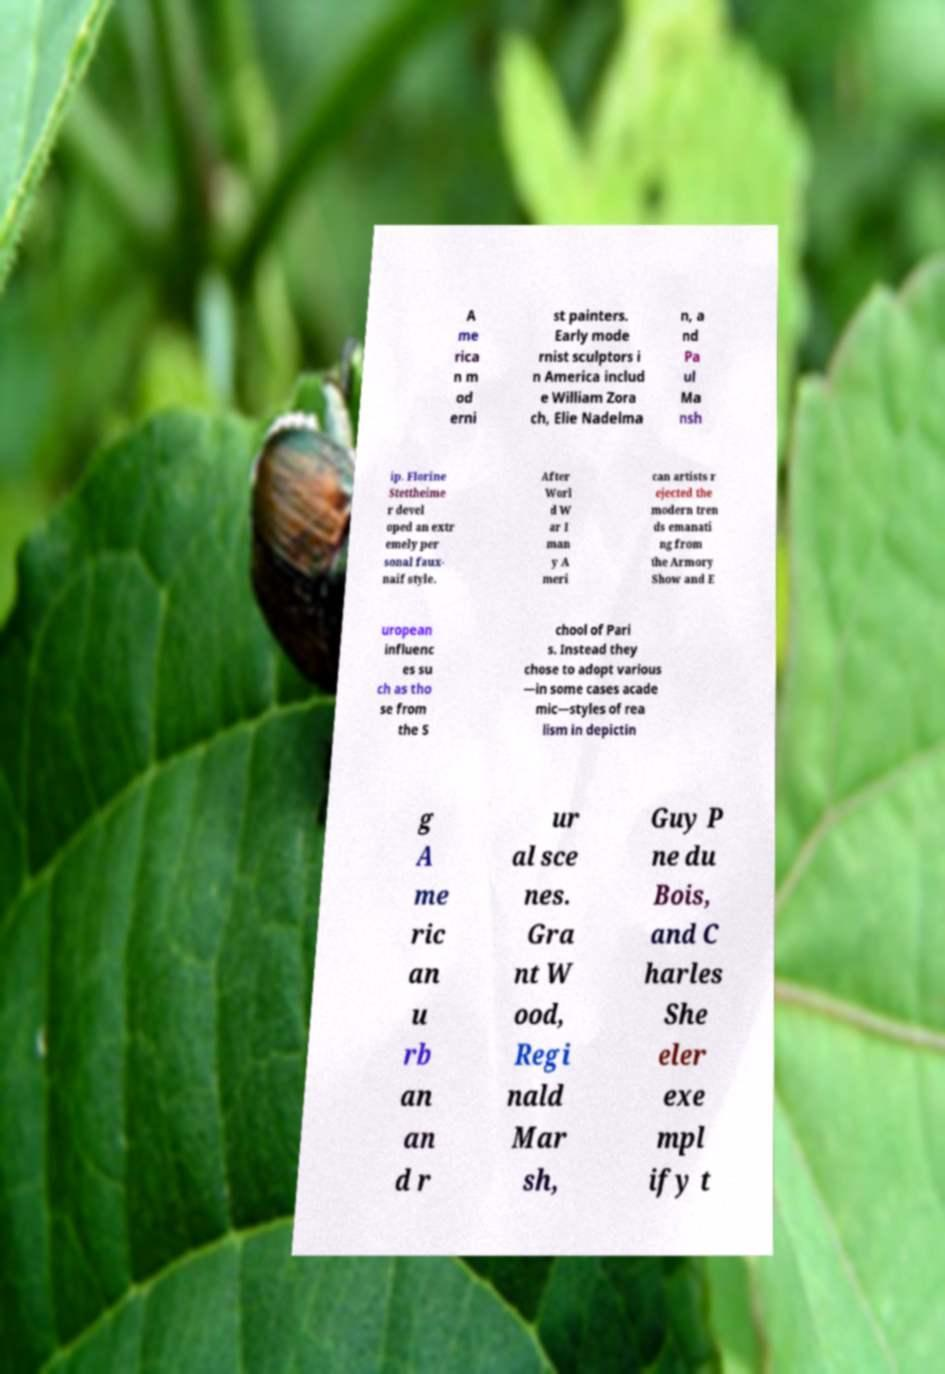Could you extract and type out the text from this image? A me rica n m od erni st painters. Early mode rnist sculptors i n America includ e William Zora ch, Elie Nadelma n, a nd Pa ul Ma nsh ip. Florine Stettheime r devel oped an extr emely per sonal faux- naif style. After Worl d W ar I man y A meri can artists r ejected the modern tren ds emanati ng from the Armory Show and E uropean influenc es su ch as tho se from the S chool of Pari s. Instead they chose to adopt various —in some cases acade mic—styles of rea lism in depictin g A me ric an u rb an an d r ur al sce nes. Gra nt W ood, Regi nald Mar sh, Guy P ne du Bois, and C harles She eler exe mpl ify t 